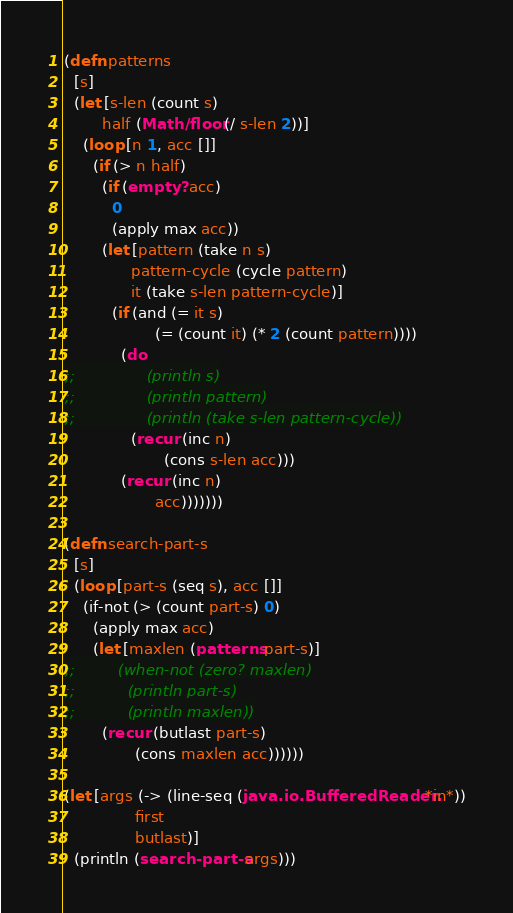<code> <loc_0><loc_0><loc_500><loc_500><_Clojure_>(defn patterns
  [s]
  (let [s-len (count s)
        half (Math/floor (/ s-len 2))]
    (loop [n 1, acc []]
      (if (> n half)
        (if (empty? acc)
          0
          (apply max acc))
        (let [pattern (take n s)
              pattern-cycle (cycle pattern)
              it (take s-len pattern-cycle)]
          (if (and (= it s)
                   (= (count it) (* 2 (count pattern))))
            (do
;;               (println s)
;;               (println pattern)
;;               (println (take s-len pattern-cycle))
              (recur (inc n)
                     (cons s-len acc)))
            (recur (inc n)
                   acc)))))))

(defn search-part-s
  [s]
  (loop [part-s (seq s), acc []]
    (if-not (> (count part-s) 0)
      (apply max acc)
      (let [maxlen (patterns part-s)]
;;         (when-not (zero? maxlen)
;;           (println part-s)
;;           (println maxlen))
        (recur (butlast part-s)
               (cons maxlen acc))))))

(let [args (-> (line-seq (java.io.BufferedReader. *in*))
               first
               butlast)]
  (println (search-part-s args)))
</code> 